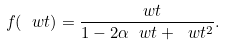Convert formula to latex. <formula><loc_0><loc_0><loc_500><loc_500>f ( \ w t ) = \frac { \ w t } { 1 - 2 \alpha \ w t + \ w t ^ { 2 } } .</formula> 